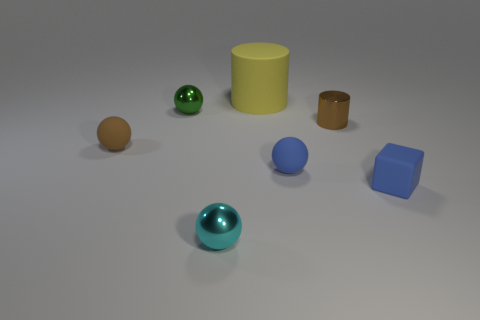How many things are either metal cylinders or things to the right of the rubber cylinder?
Offer a terse response. 3. Is the number of rubber things behind the small matte cube less than the number of metallic things in front of the tiny blue sphere?
Give a very brief answer. No. How many other things are there of the same material as the big thing?
Offer a very short reply. 3. Does the small rubber ball that is on the left side of the large object have the same color as the big object?
Make the answer very short. No. There is a small brown thing that is left of the cyan ball; is there a tiny blue thing behind it?
Make the answer very short. No. What is the small thing that is behind the brown rubber thing and on the left side of the small cylinder made of?
Give a very brief answer. Metal. There is a blue object that is made of the same material as the blue sphere; what is its shape?
Offer a terse response. Cube. Is there any other thing that is the same shape as the tiny green thing?
Make the answer very short. Yes. Does the tiny object that is behind the brown shiny object have the same material as the tiny blue ball?
Ensure brevity in your answer.  No. What is the material of the block to the right of the metallic cylinder?
Ensure brevity in your answer.  Rubber. 